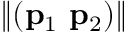Convert formula to latex. <formula><loc_0><loc_0><loc_500><loc_500>\| ( p _ { 1 } p _ { 2 } ) \|</formula> 